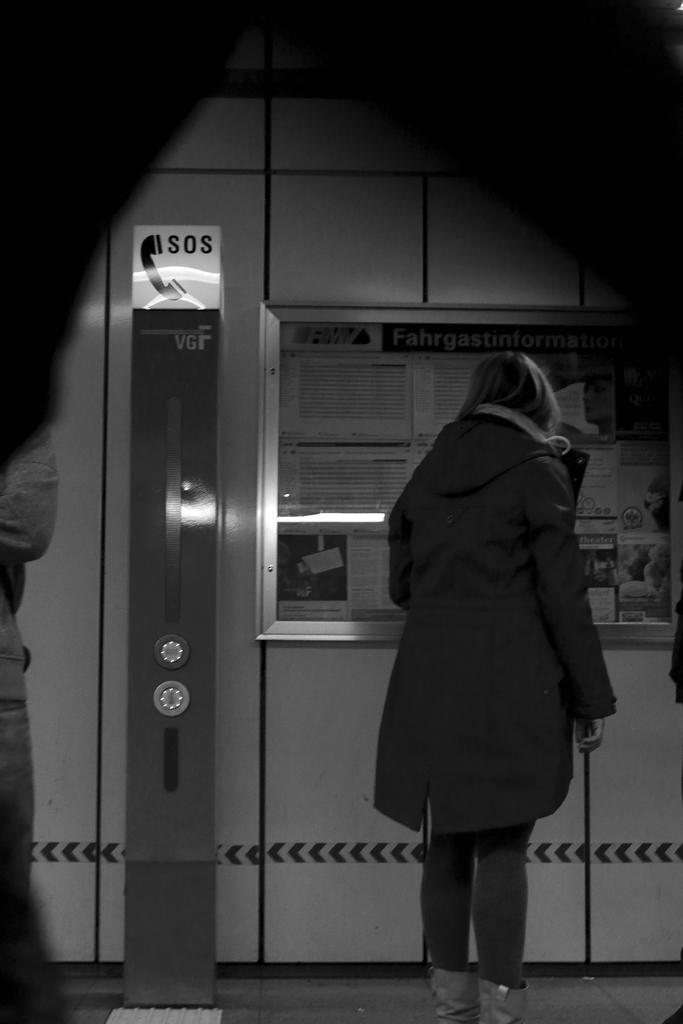<image>
Write a terse but informative summary of the picture. a machine next to a window that is labeled as VGF 